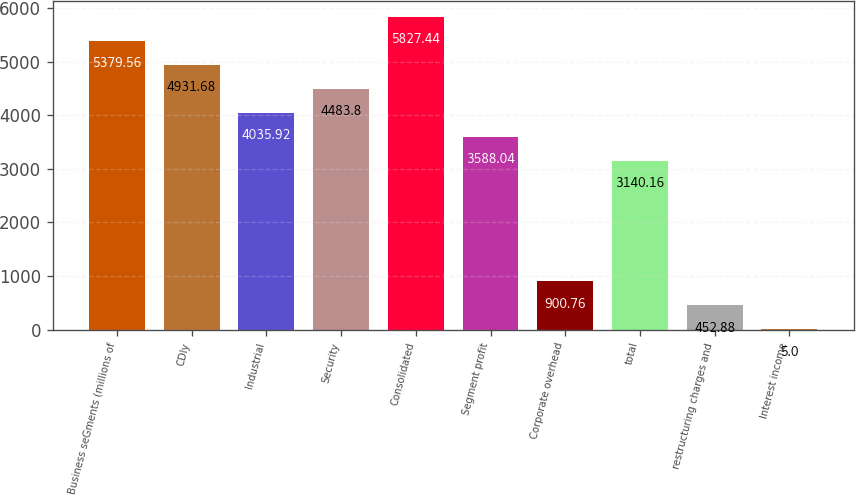Convert chart to OTSL. <chart><loc_0><loc_0><loc_500><loc_500><bar_chart><fcel>Business seGments (millions of<fcel>CDIy<fcel>Industrial<fcel>Security<fcel>Consolidated<fcel>Segment profit<fcel>Corporate overhead<fcel>total<fcel>restructuring charges and<fcel>Interest income<nl><fcel>5379.56<fcel>4931.68<fcel>4035.92<fcel>4483.8<fcel>5827.44<fcel>3588.04<fcel>900.76<fcel>3140.16<fcel>452.88<fcel>5<nl></chart> 